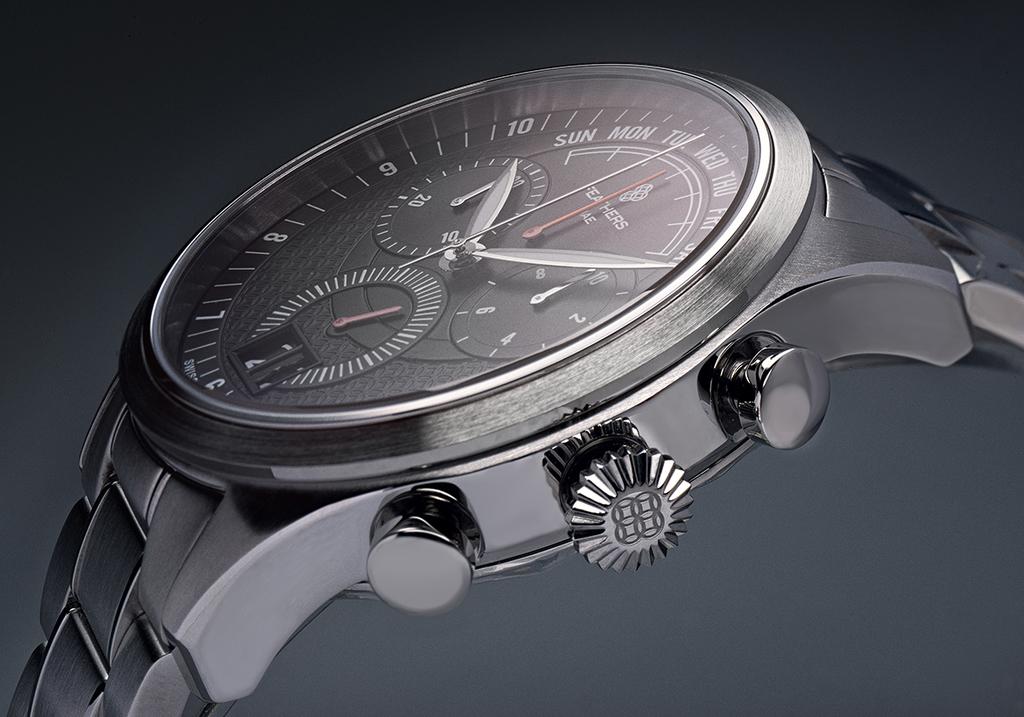What time does the watch read?
Offer a very short reply. 10:10. What brand watch is this?
Keep it short and to the point. Feathers. 